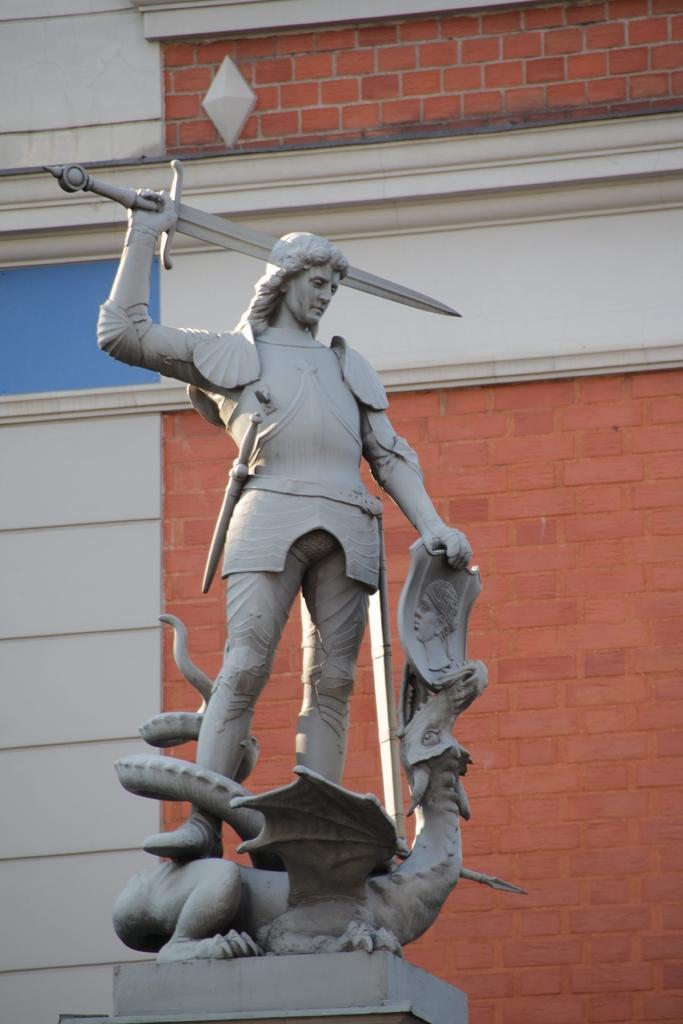Describe this image in one or two sentences. In this picture we can see a statue of a person holding a sword with hand and in the background we can see wall. 